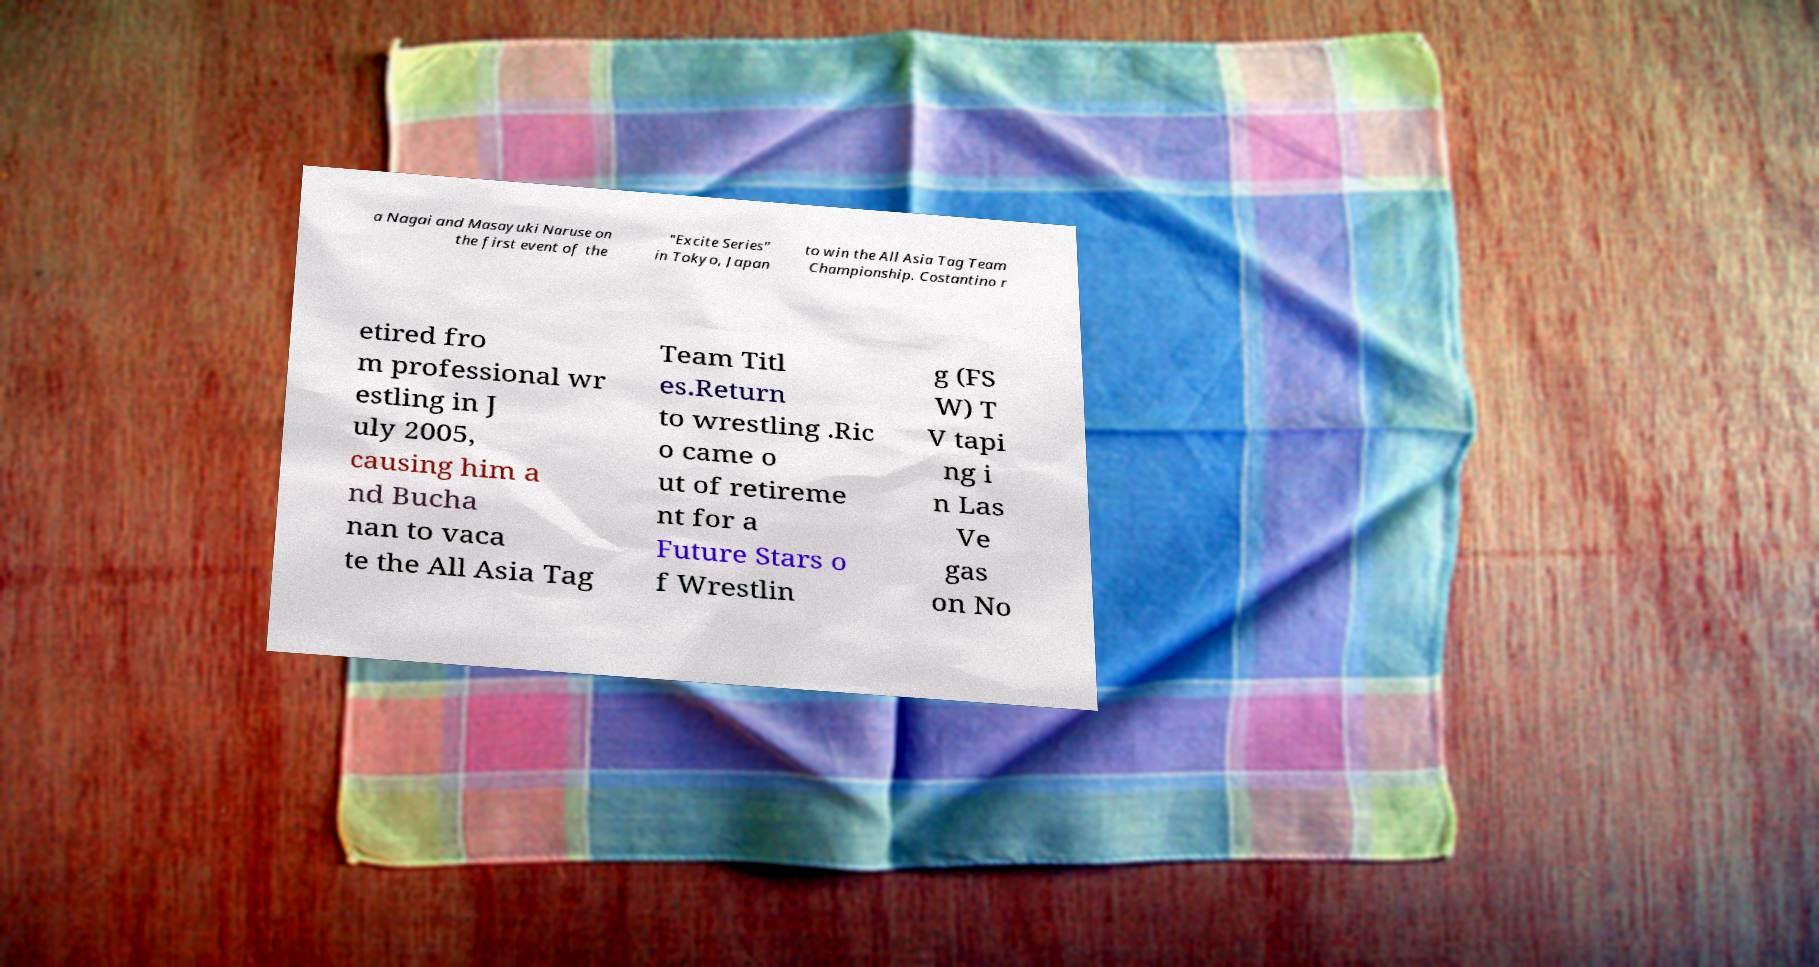What messages or text are displayed in this image? I need them in a readable, typed format. a Nagai and Masayuki Naruse on the first event of the "Excite Series" in Tokyo, Japan to win the All Asia Tag Team Championship. Costantino r etired fro m professional wr estling in J uly 2005, causing him a nd Bucha nan to vaca te the All Asia Tag Team Titl es.Return to wrestling .Ric o came o ut of retireme nt for a Future Stars o f Wrestlin g (FS W) T V tapi ng i n Las Ve gas on No 